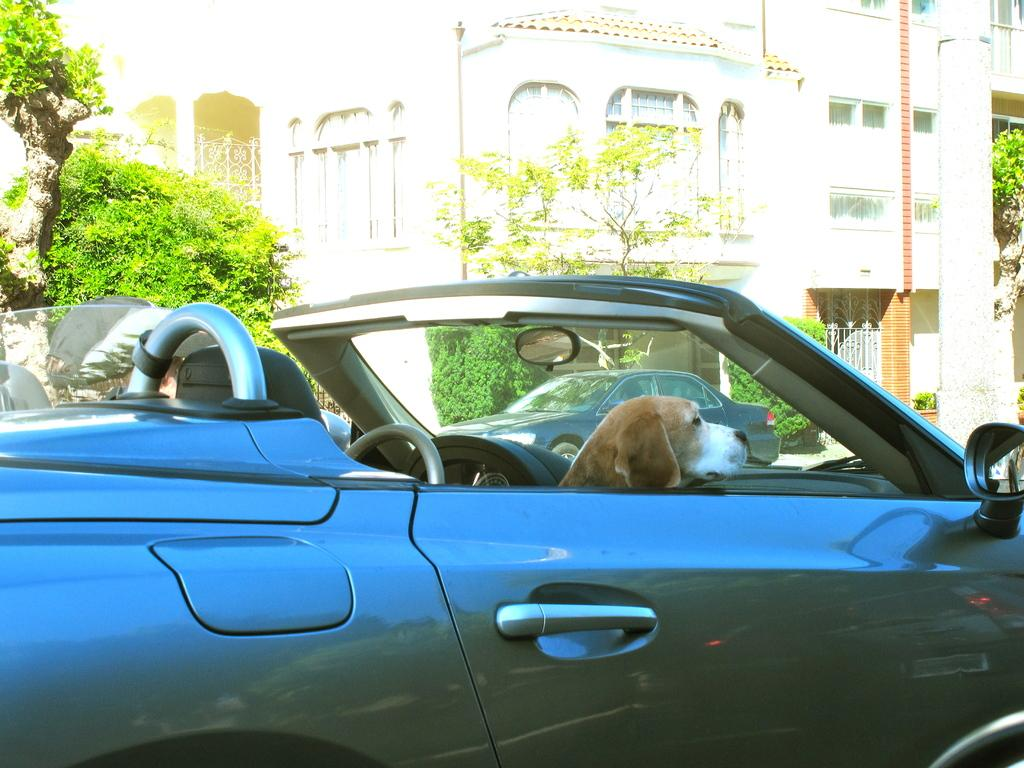What is the dog doing in the image? The dog is sitting in a car. car. Can you describe the car the dog is sitting in? The car has no roof. What can be seen in the background of the image? There are buildings and trees visible in the image. Is there another car in the image? Yes, there is another car beside the roofless car. What type of chalk is the dog using to draw on the shoes in the image? There is no chalk or shoes present in the image; it features a dog sitting in a roofless car with another car beside it and a background of buildings and trees. 